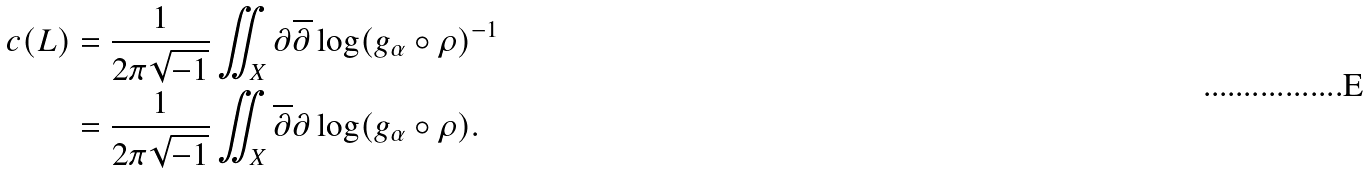Convert formula to latex. <formula><loc_0><loc_0><loc_500><loc_500>c ( L ) & = \frac { 1 } { 2 \pi \sqrt { - 1 } } \iint _ { X } \partial \overline { \partial } \log ( g _ { \alpha } \circ \rho ) ^ { - 1 } \\ & = \frac { 1 } { 2 \pi \sqrt { - 1 } } \iint _ { X } \overline { \partial } \partial \log ( g _ { \alpha } \circ \rho ) .</formula> 